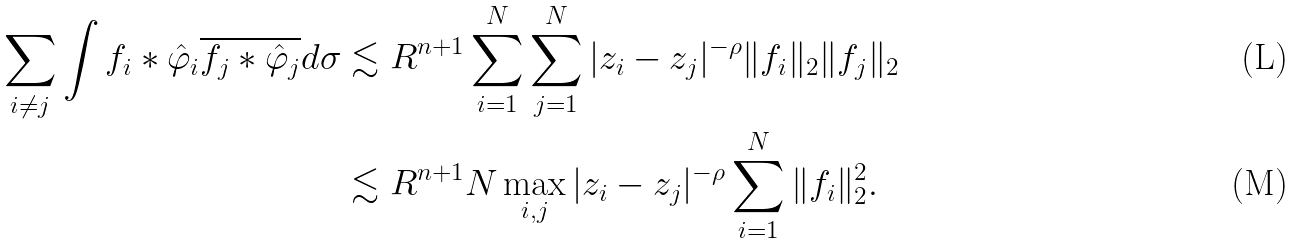Convert formula to latex. <formula><loc_0><loc_0><loc_500><loc_500>\sum _ { i \neq j } \int f _ { i } \ast \hat { \varphi } _ { i } \overline { f _ { j } \ast \hat { \varphi } _ { j } } d \sigma & \lesssim R ^ { n + 1 } \sum _ { i = 1 } ^ { N } \sum _ { j = 1 } ^ { N } | z _ { i } - z _ { j } | ^ { - \rho } \| f _ { i } \| _ { 2 } \| f _ { j } \| _ { 2 } \\ & \lesssim R ^ { n + 1 } N \max _ { i , j } | z _ { i } - z _ { j } | ^ { - \rho } \sum _ { i = 1 } ^ { N } \| f _ { i } \| _ { 2 } ^ { 2 } .</formula> 